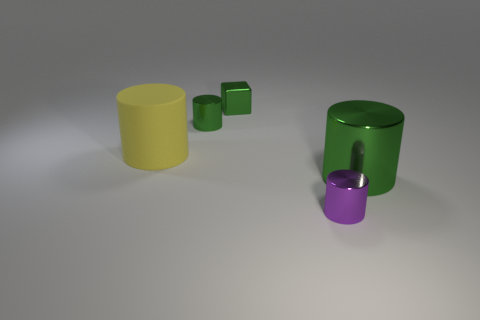Add 2 purple cylinders. How many objects exist? 7 Subtract all cylinders. How many objects are left? 1 Add 1 large objects. How many large objects exist? 3 Subtract 0 cyan spheres. How many objects are left? 5 Subtract all big blue things. Subtract all tiny purple cylinders. How many objects are left? 4 Add 2 tiny cylinders. How many tiny cylinders are left? 4 